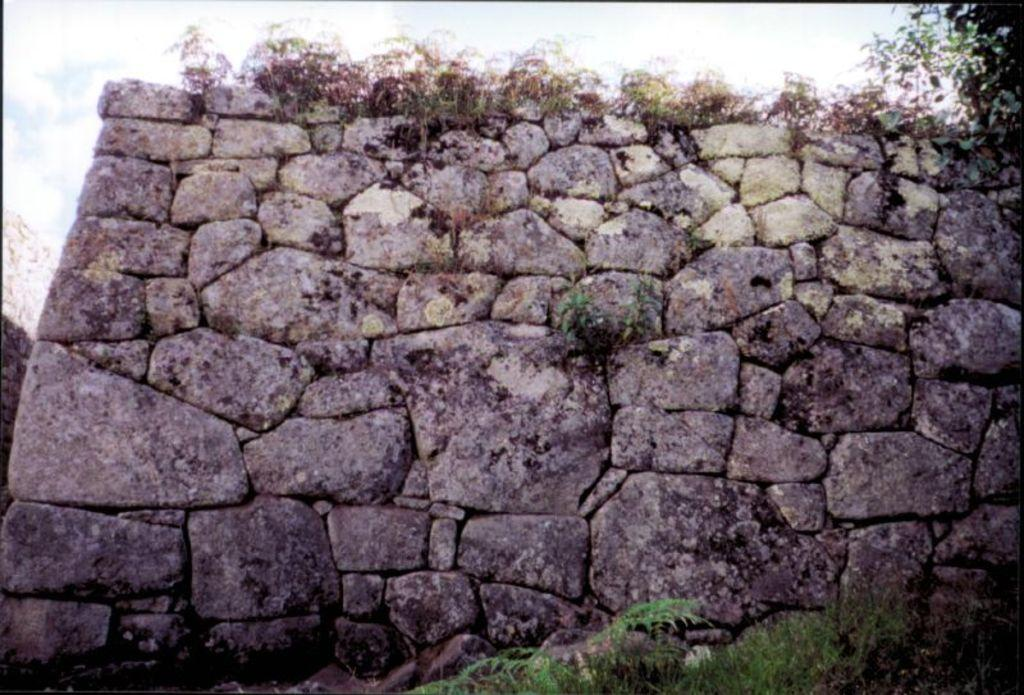What type of wall is shown in the image? The image features a wall built with rocks. What can be seen growing near the wall? There are plants visible in the image. Is there any large vegetation present in the image? Yes, there appears to be a tree in the image. How many sisters are sitting under the tree in the image? There are no people, including sisters, present in the image. 